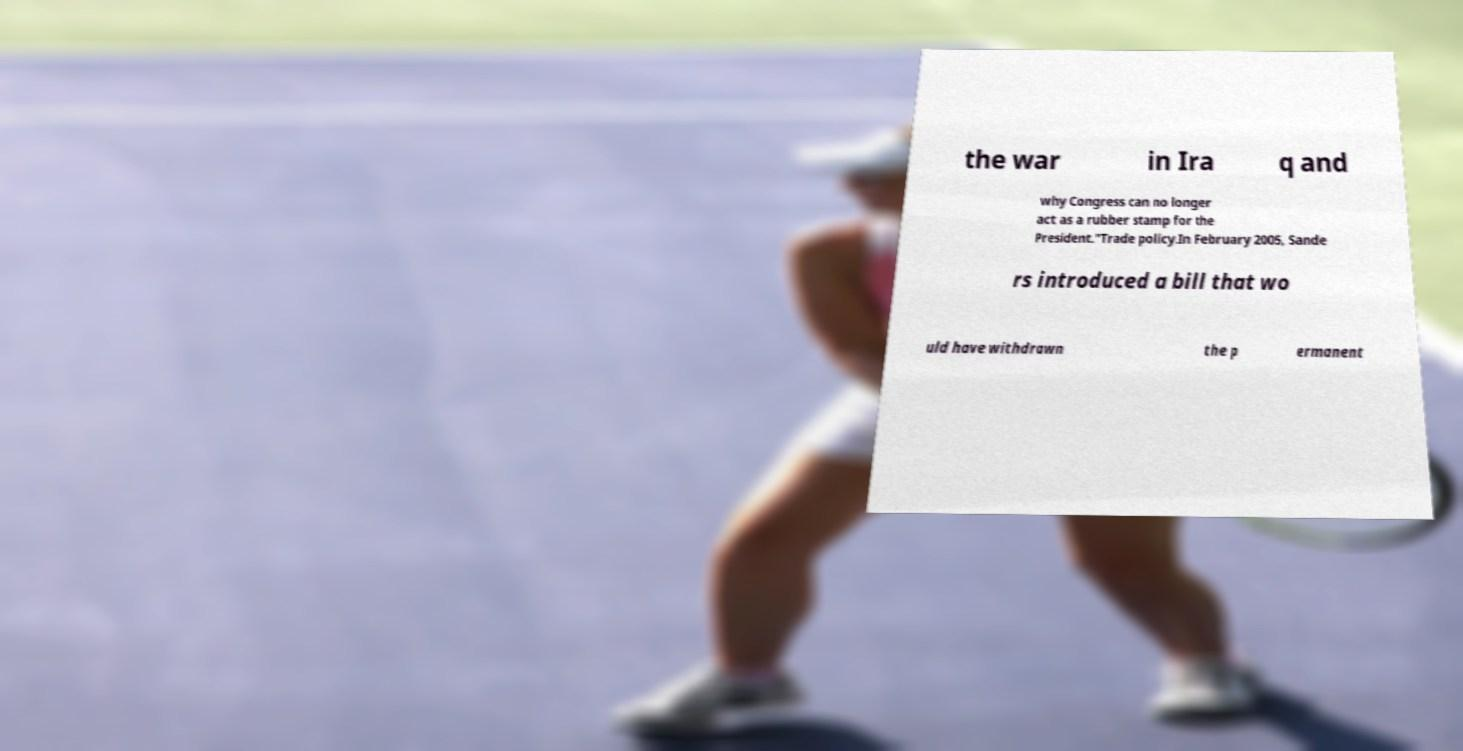Please identify and transcribe the text found in this image. the war in Ira q and why Congress can no longer act as a rubber stamp for the President."Trade policy.In February 2005, Sande rs introduced a bill that wo uld have withdrawn the p ermanent 